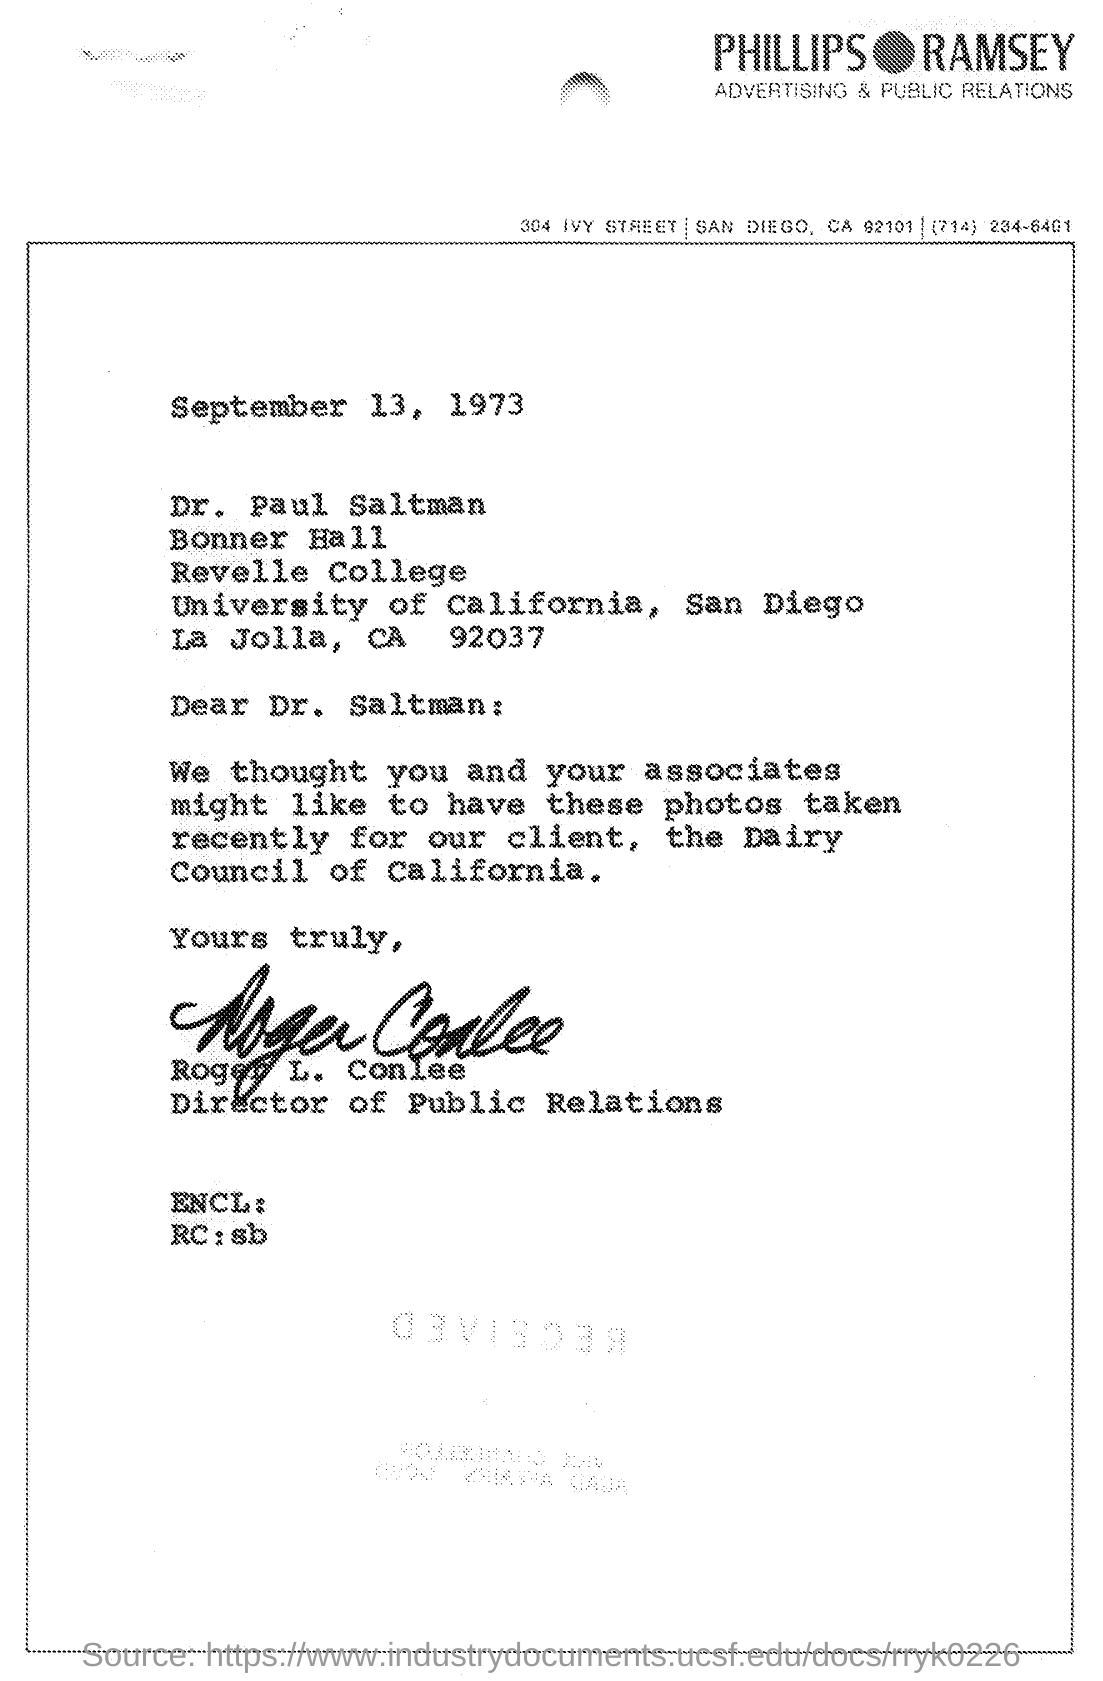Draw attention to some important aspects in this diagram. Roger L. Conlee's signature was present at the end of the letter. The date mentioned in the given letter is September 13, 1973. Roger L. Conlee is the director of public relations, as denoted by his designation. Advertising and public relations are two distinct fields of marketing communication, as mentioned on the given page. 